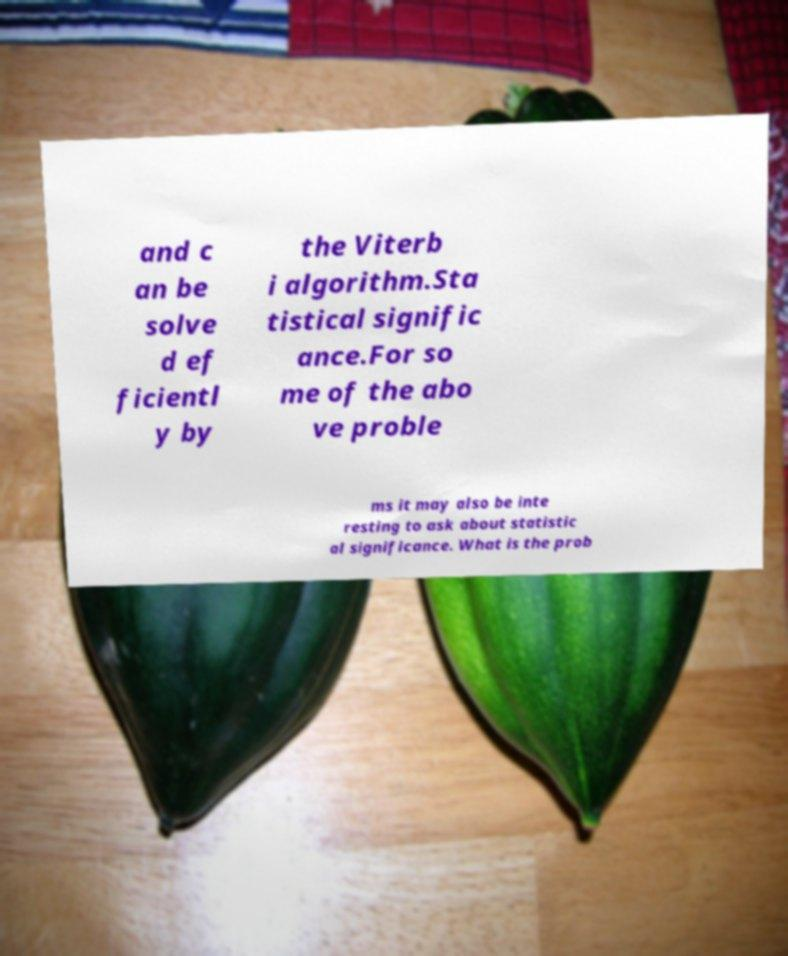For documentation purposes, I need the text within this image transcribed. Could you provide that? and c an be solve d ef ficientl y by the Viterb i algorithm.Sta tistical signific ance.For so me of the abo ve proble ms it may also be inte resting to ask about statistic al significance. What is the prob 